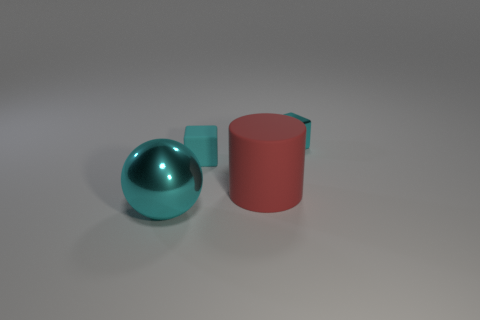Add 4 tiny cyan blocks. How many objects exist? 8 Subtract all cylinders. How many objects are left? 3 Subtract all cyan objects. Subtract all rubber cylinders. How many objects are left? 0 Add 1 small cyan objects. How many small cyan objects are left? 3 Add 1 big green metal things. How many big green metal things exist? 1 Subtract 0 blue cubes. How many objects are left? 4 